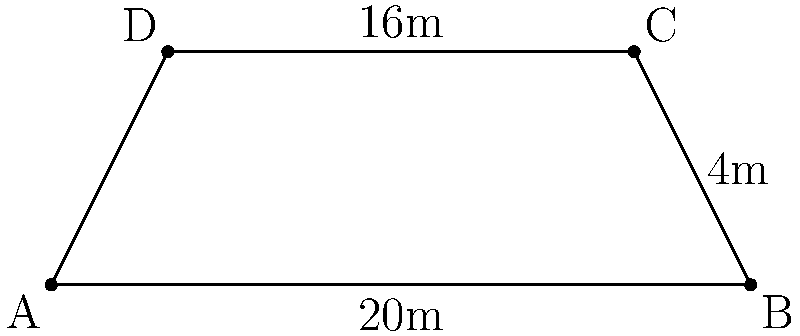As a logistics coordinator, you're tasked with optimizing storage space in a new trapezoidal warehouse. The floor plan has parallel sides of 20m and 16m, with a height of 4m between them. Calculate the total floor area of this warehouse to determine its storage capacity. To find the area of a trapezoid, we use the formula:

$$ A = \frac{1}{2}(b_1 + b_2)h $$

Where:
$A$ = area
$b_1$ = length of one parallel side
$b_2$ = length of the other parallel side
$h$ = height (perpendicular distance between parallel sides)

Given:
$b_1 = 20$ m
$b_2 = 16$ m
$h = 4$ m

Step 1: Substitute the values into the formula:
$$ A = \frac{1}{2}(20 + 16) \cdot 4 $$

Step 2: Simplify inside the parentheses:
$$ A = \frac{1}{2}(36) \cdot 4 $$

Step 3: Multiply:
$$ A = 18 \cdot 4 = 72 $$

Therefore, the total floor area of the warehouse is 72 square meters.
Answer: 72 m² 